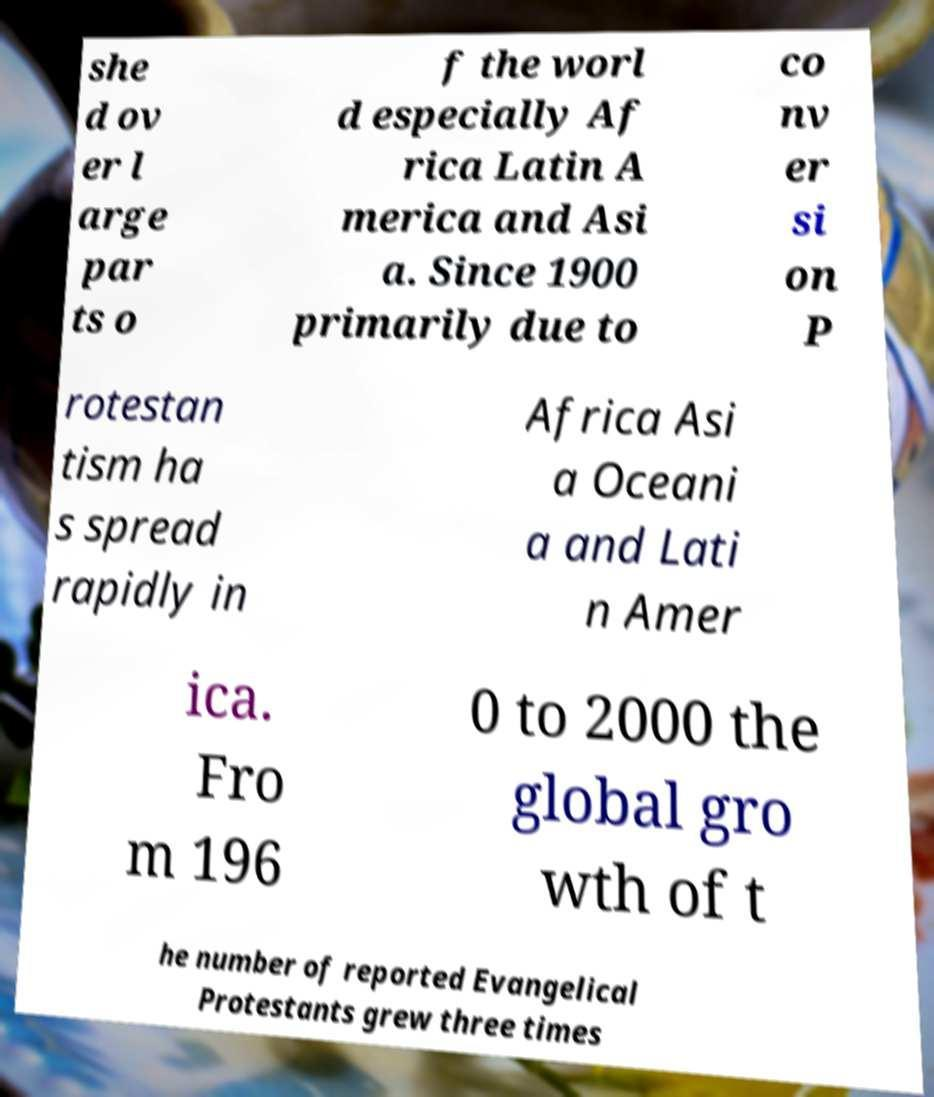I need the written content from this picture converted into text. Can you do that? she d ov er l arge par ts o f the worl d especially Af rica Latin A merica and Asi a. Since 1900 primarily due to co nv er si on P rotestan tism ha s spread rapidly in Africa Asi a Oceani a and Lati n Amer ica. Fro m 196 0 to 2000 the global gro wth of t he number of reported Evangelical Protestants grew three times 